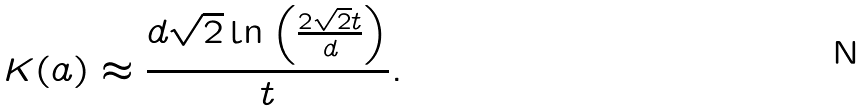Convert formula to latex. <formula><loc_0><loc_0><loc_500><loc_500>K ( a ) \approx \frac { d \sqrt { 2 } \ln { \left ( \frac { 2 \sqrt { 2 } t } { d } \right ) } } { t } .</formula> 